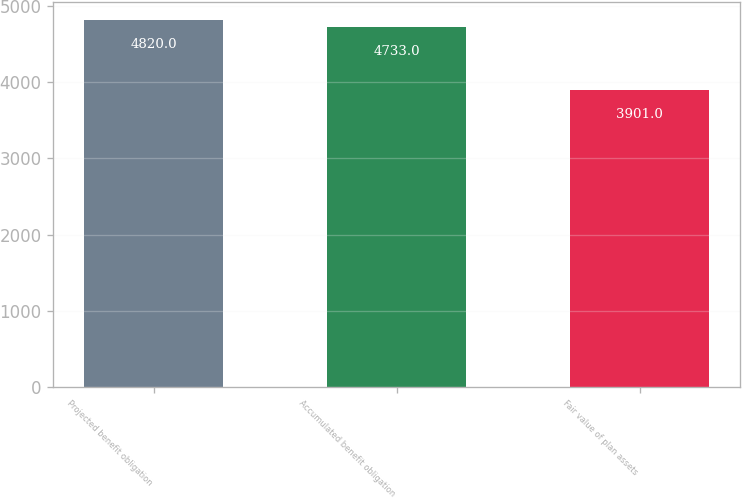Convert chart. <chart><loc_0><loc_0><loc_500><loc_500><bar_chart><fcel>Projected benefit obligation<fcel>Accumulated benefit obligation<fcel>Fair value of plan assets<nl><fcel>4820<fcel>4733<fcel>3901<nl></chart> 